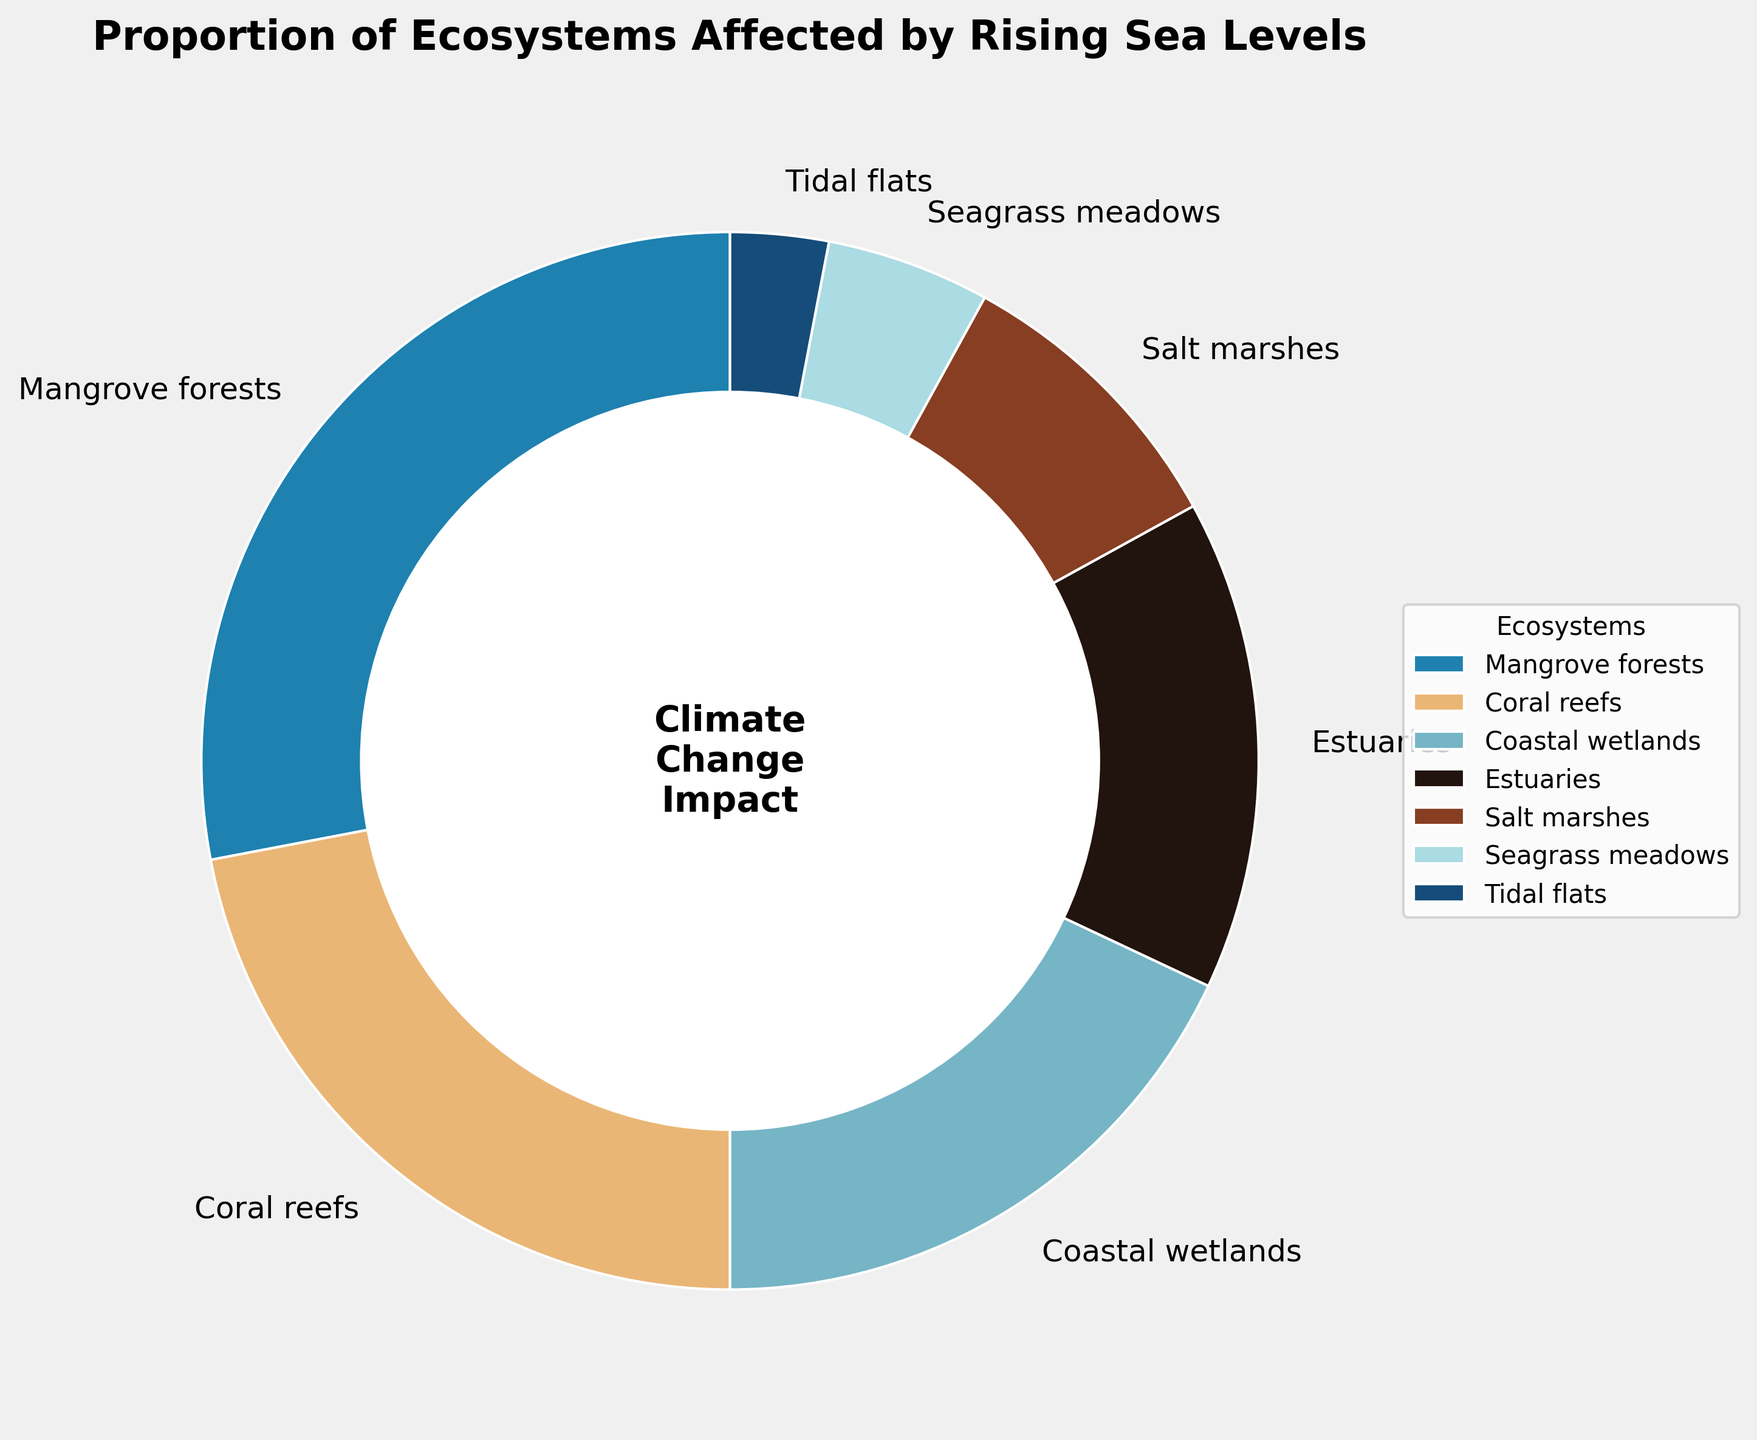What's the largest affected ecosystem according to the figure? Identify the ecosystem with the largest percentage on the pie chart. The section labeled "Mangrove forests" occupies the largest portion at 28%.
Answer: Mangrove forests Which two ecosystems combined have a larger proportion than Coral reefs? Look for ecosystems whose combined total percentage exceeds that of Coral reefs (22%). Coastal wetlands (18%) and Estuaries (15%) together total 33%, which is greater than 22%.
Answer: Coastal wetlands and Estuaries Are Salt marshes affected more than Seagrass meadows? Compare the percentage of Salt marshes (9%) to that of Seagrass meadows (5%). 9% is greater than 5%.
Answer: Yes What's the difference in impact between the most affected and the least affected ecosystems? Subtract the percentage of the least affected ecosystem (Tidal flats at 3%) from the most affected ecosystem (Mangrove forests at 28%). 28% - 3% = 25%.
Answer: 25% Which ecosystems together cover exactly half of the total impact? Sum the percentages of ecosystems to find which total exactly 50%. Mangrove forests (28%) and Coral reefs (22%) together make 50%.
Answer: Mangrove forests and Coral reefs Among coastal wetlands, Estuaries, and Salt marshes, which has the smallest impact? Compare the percentages: Coastal wetlands (18%), Estuaries (15%), Salt marshes (9%). Salt marshes has the smallest impact.
Answer: Salt marshes What is the sum of the percentages for all ecosystems listed in the pie chart? Add the percentages of all ecosystems: 28% (Mangrove forests) + 22% (Coral reefs) + 18% (Coastal wetlands) + 15% (Estuaries) + 9% (Salt marshes) + 5% (Seagrass meadows) + 3% (Tidal flats). The total is 100%.
Answer: 100% How much more affected are Estuaries than Tidal flats? Subtract the percentage for Tidal flats (3%) from the percentage for Estuaries (15%). 15% - 3% = 12%.
Answer: 12% What is the combined impact percentage of ecosystems that fall below 10% each? Sum the percentages for ecosystems with less than 10%: Salt marshes (9%), Seagrass meadows (5%), Tidal flats (3%). 9% + 5% + 3% = 17%.
Answer: 17% If you rank the ecosystems from most to least affected, which ecosystem is third in rank? Order the ecosystems by their percentages: Mangrove forests (28%), Coral reefs (22%), Coastal wetlands (18%). Coastal wetlands is the third in rank.
Answer: Coastal wetlands 